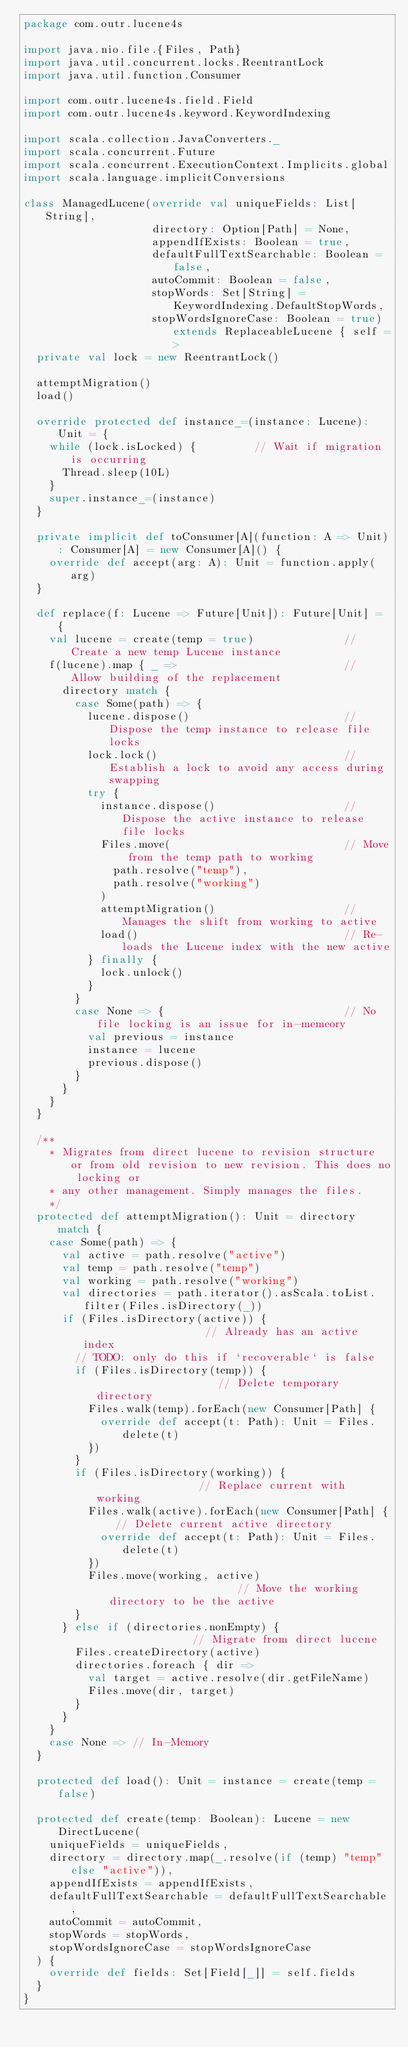Convert code to text. <code><loc_0><loc_0><loc_500><loc_500><_Scala_>package com.outr.lucene4s

import java.nio.file.{Files, Path}
import java.util.concurrent.locks.ReentrantLock
import java.util.function.Consumer

import com.outr.lucene4s.field.Field
import com.outr.lucene4s.keyword.KeywordIndexing

import scala.collection.JavaConverters._
import scala.concurrent.Future
import scala.concurrent.ExecutionContext.Implicits.global
import scala.language.implicitConversions

class ManagedLucene(override val uniqueFields: List[String],
                    directory: Option[Path] = None,
                    appendIfExists: Boolean = true,
                    defaultFullTextSearchable: Boolean = false,
                    autoCommit: Boolean = false,
                    stopWords: Set[String] = KeywordIndexing.DefaultStopWords,
                    stopWordsIgnoreCase: Boolean = true) extends ReplaceableLucene { self =>
  private val lock = new ReentrantLock()

  attemptMigration()
  load()

  override protected def instance_=(instance: Lucene): Unit = {
    while (lock.isLocked) {         // Wait if migration is occurring
      Thread.sleep(10L)
    }
    super.instance_=(instance)
  }

  private implicit def toConsumer[A](function: A => Unit): Consumer[A] = new Consumer[A]() {
    override def accept(arg: A): Unit = function.apply(arg)
  }

  def replace(f: Lucene => Future[Unit]): Future[Unit] = {
    val lucene = create(temp = true)              // Create a new temp Lucene instance
    f(lucene).map { _ =>                          // Allow building of the replacement
      directory match {
        case Some(path) => {
          lucene.dispose()                        // Dispose the temp instance to release file locks
          lock.lock()                             // Establish a lock to avoid any access during swapping
          try {
            instance.dispose()                    // Dispose the active instance to release file locks
            Files.move(                           // Move from the temp path to working
              path.resolve("temp"),
              path.resolve("working")
            )
            attemptMigration()                    // Manages the shift from working to active
            load()                                // Re-loads the Lucene index with the new active
          } finally {
            lock.unlock()
          }
        }
        case None => {                            // No file locking is an issue for in-memeory
          val previous = instance
          instance = lucene
          previous.dispose()
        }
      }
    }
  }

  /**
    * Migrates from direct lucene to revision structure or from old revision to new revision. This does no locking or
    * any other management. Simply manages the files.
    */
  protected def attemptMigration(): Unit = directory match {
    case Some(path) => {
      val active = path.resolve("active")
      val temp = path.resolve("temp")
      val working = path.resolve("working")
      val directories = path.iterator().asScala.toList.filter(Files.isDirectory(_))
      if (Files.isDirectory(active)) {                    // Already has an active index
        // TODO: only do this if `recoverable` is false
        if (Files.isDirectory(temp)) {                    // Delete temporary directory
          Files.walk(temp).forEach(new Consumer[Path] {
            override def accept(t: Path): Unit = Files.delete(t)
          })
        }
        if (Files.isDirectory(working)) {                 // Replace current with working
          Files.walk(active).forEach(new Consumer[Path] { // Delete current active directory
            override def accept(t: Path): Unit = Files.delete(t)
          })
          Files.move(working, active)                     // Move the working directory to be the active
        }
      } else if (directories.nonEmpty) {                  // Migrate from direct lucene
        Files.createDirectory(active)
        directories.foreach { dir =>
          val target = active.resolve(dir.getFileName)
          Files.move(dir, target)
        }
      }
    }
    case None => // In-Memory
  }

  protected def load(): Unit = instance = create(temp = false)

  protected def create(temp: Boolean): Lucene = new DirectLucene(
    uniqueFields = uniqueFields,
    directory = directory.map(_.resolve(if (temp) "temp" else "active")),
    appendIfExists = appendIfExists,
    defaultFullTextSearchable = defaultFullTextSearchable,
    autoCommit = autoCommit,
    stopWords = stopWords,
    stopWordsIgnoreCase = stopWordsIgnoreCase
  ) {
    override def fields: Set[Field[_]] = self.fields
  }
}</code> 